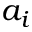Convert formula to latex. <formula><loc_0><loc_0><loc_500><loc_500>a _ { i }</formula> 